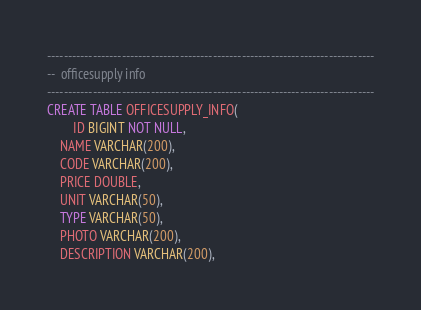<code> <loc_0><loc_0><loc_500><loc_500><_SQL_>

-------------------------------------------------------------------------------
--  officesupply info
-------------------------------------------------------------------------------
CREATE TABLE OFFICESUPPLY_INFO(
        ID BIGINT NOT NULL,
	NAME VARCHAR(200),
	CODE VARCHAR(200),
	PRICE DOUBLE,
	UNIT VARCHAR(50),
	TYPE VARCHAR(50),
	PHOTO VARCHAR(200),
	DESCRIPTION VARCHAR(200),</code> 